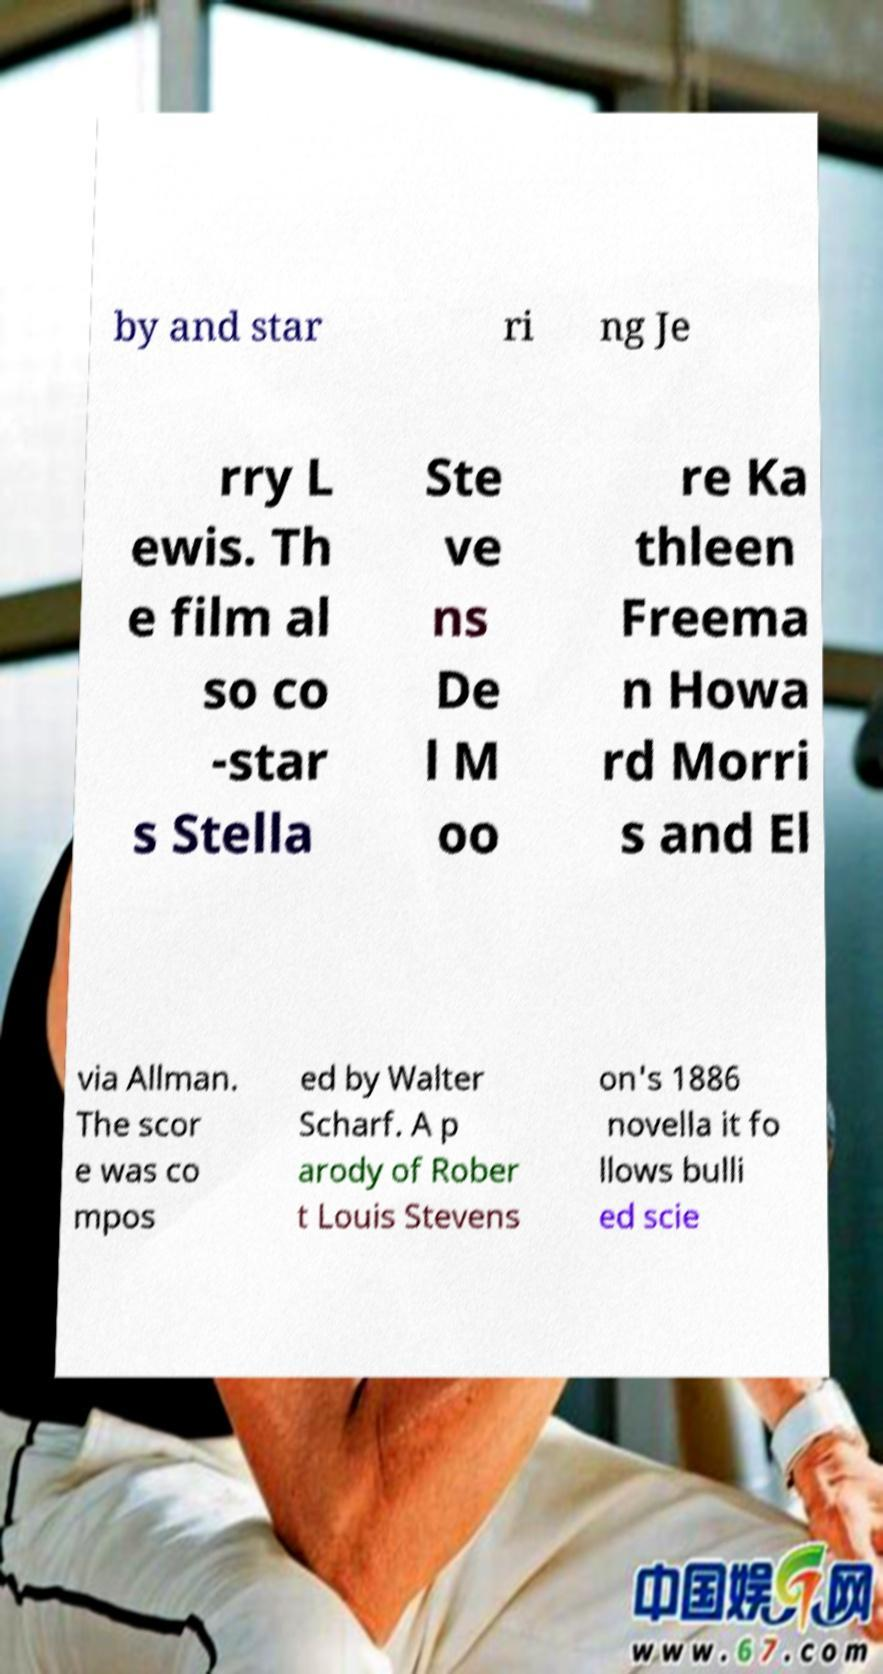Can you read and provide the text displayed in the image?This photo seems to have some interesting text. Can you extract and type it out for me? by and star ri ng Je rry L ewis. Th e film al so co -star s Stella Ste ve ns De l M oo re Ka thleen Freema n Howa rd Morri s and El via Allman. The scor e was co mpos ed by Walter Scharf. A p arody of Rober t Louis Stevens on's 1886 novella it fo llows bulli ed scie 